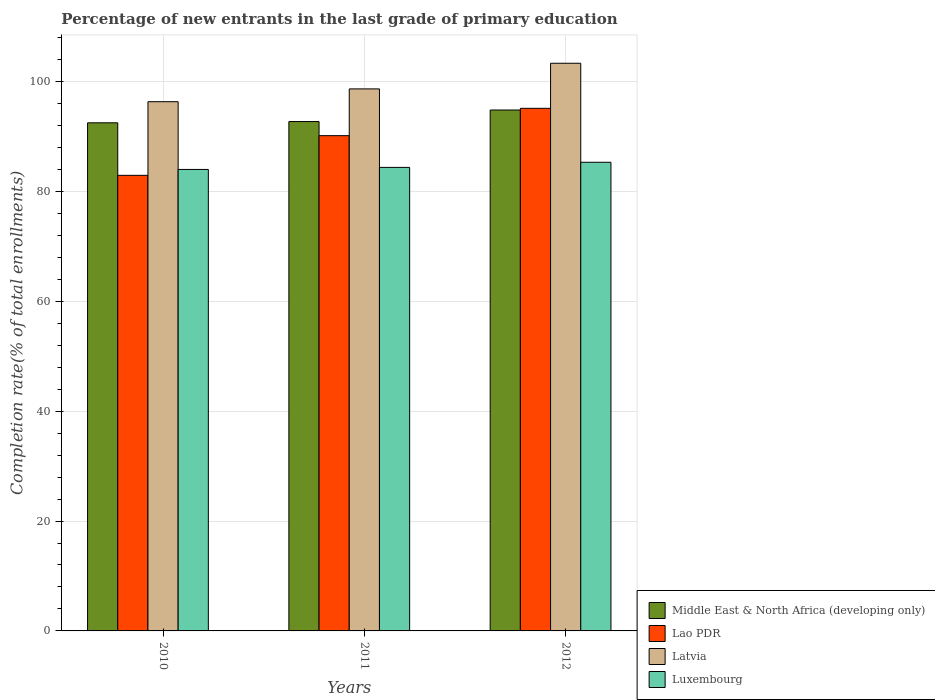How many groups of bars are there?
Provide a short and direct response. 3. Are the number of bars per tick equal to the number of legend labels?
Give a very brief answer. Yes. Are the number of bars on each tick of the X-axis equal?
Give a very brief answer. Yes. How many bars are there on the 3rd tick from the right?
Offer a terse response. 4. What is the label of the 2nd group of bars from the left?
Ensure brevity in your answer.  2011. What is the percentage of new entrants in Lao PDR in 2010?
Offer a very short reply. 82.92. Across all years, what is the maximum percentage of new entrants in Middle East & North Africa (developing only)?
Your answer should be very brief. 94.81. Across all years, what is the minimum percentage of new entrants in Middle East & North Africa (developing only)?
Provide a succinct answer. 92.48. In which year was the percentage of new entrants in Luxembourg minimum?
Ensure brevity in your answer.  2010. What is the total percentage of new entrants in Latvia in the graph?
Make the answer very short. 298.31. What is the difference between the percentage of new entrants in Luxembourg in 2010 and that in 2011?
Your answer should be very brief. -0.37. What is the difference between the percentage of new entrants in Middle East & North Africa (developing only) in 2010 and the percentage of new entrants in Luxembourg in 2012?
Your response must be concise. 7.18. What is the average percentage of new entrants in Latvia per year?
Give a very brief answer. 99.44. In the year 2010, what is the difference between the percentage of new entrants in Middle East & North Africa (developing only) and percentage of new entrants in Lao PDR?
Provide a succinct answer. 9.56. What is the ratio of the percentage of new entrants in Latvia in 2010 to that in 2012?
Offer a very short reply. 0.93. What is the difference between the highest and the second highest percentage of new entrants in Lao PDR?
Keep it short and to the point. 4.98. What is the difference between the highest and the lowest percentage of new entrants in Latvia?
Provide a short and direct response. 7. Is it the case that in every year, the sum of the percentage of new entrants in Lao PDR and percentage of new entrants in Middle East & North Africa (developing only) is greater than the sum of percentage of new entrants in Luxembourg and percentage of new entrants in Latvia?
Ensure brevity in your answer.  No. What does the 4th bar from the left in 2012 represents?
Your response must be concise. Luxembourg. What does the 2nd bar from the right in 2012 represents?
Your response must be concise. Latvia. Is it the case that in every year, the sum of the percentage of new entrants in Luxembourg and percentage of new entrants in Middle East & North Africa (developing only) is greater than the percentage of new entrants in Latvia?
Your answer should be compact. Yes. Does the graph contain grids?
Offer a very short reply. Yes. Where does the legend appear in the graph?
Make the answer very short. Bottom right. How are the legend labels stacked?
Offer a very short reply. Vertical. What is the title of the graph?
Ensure brevity in your answer.  Percentage of new entrants in the last grade of primary education. Does "Belgium" appear as one of the legend labels in the graph?
Offer a very short reply. No. What is the label or title of the Y-axis?
Your response must be concise. Completion rate(% of total enrollments). What is the Completion rate(% of total enrollments) in Middle East & North Africa (developing only) in 2010?
Keep it short and to the point. 92.48. What is the Completion rate(% of total enrollments) of Lao PDR in 2010?
Offer a very short reply. 82.92. What is the Completion rate(% of total enrollments) in Latvia in 2010?
Offer a very short reply. 96.33. What is the Completion rate(% of total enrollments) in Luxembourg in 2010?
Your answer should be compact. 84. What is the Completion rate(% of total enrollments) in Middle East & North Africa (developing only) in 2011?
Offer a terse response. 92.71. What is the Completion rate(% of total enrollments) in Lao PDR in 2011?
Offer a very short reply. 90.14. What is the Completion rate(% of total enrollments) in Latvia in 2011?
Ensure brevity in your answer.  98.66. What is the Completion rate(% of total enrollments) of Luxembourg in 2011?
Offer a terse response. 84.37. What is the Completion rate(% of total enrollments) in Middle East & North Africa (developing only) in 2012?
Keep it short and to the point. 94.81. What is the Completion rate(% of total enrollments) of Lao PDR in 2012?
Provide a short and direct response. 95.12. What is the Completion rate(% of total enrollments) of Latvia in 2012?
Ensure brevity in your answer.  103.32. What is the Completion rate(% of total enrollments) in Luxembourg in 2012?
Your response must be concise. 85.3. Across all years, what is the maximum Completion rate(% of total enrollments) in Middle East & North Africa (developing only)?
Offer a terse response. 94.81. Across all years, what is the maximum Completion rate(% of total enrollments) of Lao PDR?
Offer a very short reply. 95.12. Across all years, what is the maximum Completion rate(% of total enrollments) of Latvia?
Give a very brief answer. 103.32. Across all years, what is the maximum Completion rate(% of total enrollments) in Luxembourg?
Make the answer very short. 85.3. Across all years, what is the minimum Completion rate(% of total enrollments) in Middle East & North Africa (developing only)?
Your answer should be very brief. 92.48. Across all years, what is the minimum Completion rate(% of total enrollments) in Lao PDR?
Keep it short and to the point. 82.92. Across all years, what is the minimum Completion rate(% of total enrollments) of Latvia?
Offer a very short reply. 96.33. Across all years, what is the minimum Completion rate(% of total enrollments) in Luxembourg?
Provide a short and direct response. 84. What is the total Completion rate(% of total enrollments) in Middle East & North Africa (developing only) in the graph?
Offer a terse response. 280.01. What is the total Completion rate(% of total enrollments) in Lao PDR in the graph?
Ensure brevity in your answer.  268.19. What is the total Completion rate(% of total enrollments) in Latvia in the graph?
Offer a very short reply. 298.31. What is the total Completion rate(% of total enrollments) of Luxembourg in the graph?
Offer a terse response. 253.67. What is the difference between the Completion rate(% of total enrollments) of Middle East & North Africa (developing only) in 2010 and that in 2011?
Keep it short and to the point. -0.23. What is the difference between the Completion rate(% of total enrollments) in Lao PDR in 2010 and that in 2011?
Offer a very short reply. -7.22. What is the difference between the Completion rate(% of total enrollments) in Latvia in 2010 and that in 2011?
Your response must be concise. -2.33. What is the difference between the Completion rate(% of total enrollments) of Luxembourg in 2010 and that in 2011?
Your answer should be very brief. -0.37. What is the difference between the Completion rate(% of total enrollments) of Middle East & North Africa (developing only) in 2010 and that in 2012?
Your answer should be compact. -2.33. What is the difference between the Completion rate(% of total enrollments) of Lao PDR in 2010 and that in 2012?
Your answer should be compact. -12.2. What is the difference between the Completion rate(% of total enrollments) of Latvia in 2010 and that in 2012?
Provide a short and direct response. -7. What is the difference between the Completion rate(% of total enrollments) of Luxembourg in 2010 and that in 2012?
Ensure brevity in your answer.  -1.31. What is the difference between the Completion rate(% of total enrollments) of Middle East & North Africa (developing only) in 2011 and that in 2012?
Your answer should be very brief. -2.1. What is the difference between the Completion rate(% of total enrollments) in Lao PDR in 2011 and that in 2012?
Provide a succinct answer. -4.98. What is the difference between the Completion rate(% of total enrollments) of Latvia in 2011 and that in 2012?
Provide a succinct answer. -4.67. What is the difference between the Completion rate(% of total enrollments) in Luxembourg in 2011 and that in 2012?
Keep it short and to the point. -0.93. What is the difference between the Completion rate(% of total enrollments) in Middle East & North Africa (developing only) in 2010 and the Completion rate(% of total enrollments) in Lao PDR in 2011?
Provide a succinct answer. 2.34. What is the difference between the Completion rate(% of total enrollments) of Middle East & North Africa (developing only) in 2010 and the Completion rate(% of total enrollments) of Latvia in 2011?
Provide a short and direct response. -6.17. What is the difference between the Completion rate(% of total enrollments) of Middle East & North Africa (developing only) in 2010 and the Completion rate(% of total enrollments) of Luxembourg in 2011?
Offer a very short reply. 8.12. What is the difference between the Completion rate(% of total enrollments) of Lao PDR in 2010 and the Completion rate(% of total enrollments) of Latvia in 2011?
Provide a succinct answer. -15.73. What is the difference between the Completion rate(% of total enrollments) of Lao PDR in 2010 and the Completion rate(% of total enrollments) of Luxembourg in 2011?
Provide a succinct answer. -1.45. What is the difference between the Completion rate(% of total enrollments) in Latvia in 2010 and the Completion rate(% of total enrollments) in Luxembourg in 2011?
Your answer should be very brief. 11.96. What is the difference between the Completion rate(% of total enrollments) in Middle East & North Africa (developing only) in 2010 and the Completion rate(% of total enrollments) in Lao PDR in 2012?
Offer a terse response. -2.64. What is the difference between the Completion rate(% of total enrollments) of Middle East & North Africa (developing only) in 2010 and the Completion rate(% of total enrollments) of Latvia in 2012?
Provide a short and direct response. -10.84. What is the difference between the Completion rate(% of total enrollments) of Middle East & North Africa (developing only) in 2010 and the Completion rate(% of total enrollments) of Luxembourg in 2012?
Make the answer very short. 7.18. What is the difference between the Completion rate(% of total enrollments) of Lao PDR in 2010 and the Completion rate(% of total enrollments) of Latvia in 2012?
Your answer should be very brief. -20.4. What is the difference between the Completion rate(% of total enrollments) of Lao PDR in 2010 and the Completion rate(% of total enrollments) of Luxembourg in 2012?
Your response must be concise. -2.38. What is the difference between the Completion rate(% of total enrollments) in Latvia in 2010 and the Completion rate(% of total enrollments) in Luxembourg in 2012?
Your answer should be compact. 11.02. What is the difference between the Completion rate(% of total enrollments) of Middle East & North Africa (developing only) in 2011 and the Completion rate(% of total enrollments) of Lao PDR in 2012?
Offer a terse response. -2.41. What is the difference between the Completion rate(% of total enrollments) in Middle East & North Africa (developing only) in 2011 and the Completion rate(% of total enrollments) in Latvia in 2012?
Offer a terse response. -10.61. What is the difference between the Completion rate(% of total enrollments) of Middle East & North Africa (developing only) in 2011 and the Completion rate(% of total enrollments) of Luxembourg in 2012?
Your answer should be compact. 7.41. What is the difference between the Completion rate(% of total enrollments) in Lao PDR in 2011 and the Completion rate(% of total enrollments) in Latvia in 2012?
Offer a very short reply. -13.18. What is the difference between the Completion rate(% of total enrollments) of Lao PDR in 2011 and the Completion rate(% of total enrollments) of Luxembourg in 2012?
Provide a short and direct response. 4.84. What is the difference between the Completion rate(% of total enrollments) in Latvia in 2011 and the Completion rate(% of total enrollments) in Luxembourg in 2012?
Offer a very short reply. 13.36. What is the average Completion rate(% of total enrollments) in Middle East & North Africa (developing only) per year?
Your response must be concise. 93.34. What is the average Completion rate(% of total enrollments) of Lao PDR per year?
Keep it short and to the point. 89.4. What is the average Completion rate(% of total enrollments) in Latvia per year?
Keep it short and to the point. 99.44. What is the average Completion rate(% of total enrollments) of Luxembourg per year?
Your answer should be compact. 84.56. In the year 2010, what is the difference between the Completion rate(% of total enrollments) in Middle East & North Africa (developing only) and Completion rate(% of total enrollments) in Lao PDR?
Your answer should be compact. 9.56. In the year 2010, what is the difference between the Completion rate(% of total enrollments) of Middle East & North Africa (developing only) and Completion rate(% of total enrollments) of Latvia?
Your answer should be very brief. -3.84. In the year 2010, what is the difference between the Completion rate(% of total enrollments) in Middle East & North Africa (developing only) and Completion rate(% of total enrollments) in Luxembourg?
Offer a very short reply. 8.49. In the year 2010, what is the difference between the Completion rate(% of total enrollments) in Lao PDR and Completion rate(% of total enrollments) in Latvia?
Provide a succinct answer. -13.4. In the year 2010, what is the difference between the Completion rate(% of total enrollments) in Lao PDR and Completion rate(% of total enrollments) in Luxembourg?
Offer a terse response. -1.07. In the year 2010, what is the difference between the Completion rate(% of total enrollments) of Latvia and Completion rate(% of total enrollments) of Luxembourg?
Keep it short and to the point. 12.33. In the year 2011, what is the difference between the Completion rate(% of total enrollments) of Middle East & North Africa (developing only) and Completion rate(% of total enrollments) of Lao PDR?
Keep it short and to the point. 2.57. In the year 2011, what is the difference between the Completion rate(% of total enrollments) of Middle East & North Africa (developing only) and Completion rate(% of total enrollments) of Latvia?
Give a very brief answer. -5.94. In the year 2011, what is the difference between the Completion rate(% of total enrollments) of Middle East & North Africa (developing only) and Completion rate(% of total enrollments) of Luxembourg?
Your response must be concise. 8.34. In the year 2011, what is the difference between the Completion rate(% of total enrollments) in Lao PDR and Completion rate(% of total enrollments) in Latvia?
Keep it short and to the point. -8.51. In the year 2011, what is the difference between the Completion rate(% of total enrollments) of Lao PDR and Completion rate(% of total enrollments) of Luxembourg?
Make the answer very short. 5.78. In the year 2011, what is the difference between the Completion rate(% of total enrollments) of Latvia and Completion rate(% of total enrollments) of Luxembourg?
Ensure brevity in your answer.  14.29. In the year 2012, what is the difference between the Completion rate(% of total enrollments) of Middle East & North Africa (developing only) and Completion rate(% of total enrollments) of Lao PDR?
Your response must be concise. -0.31. In the year 2012, what is the difference between the Completion rate(% of total enrollments) in Middle East & North Africa (developing only) and Completion rate(% of total enrollments) in Latvia?
Provide a succinct answer. -8.51. In the year 2012, what is the difference between the Completion rate(% of total enrollments) of Middle East & North Africa (developing only) and Completion rate(% of total enrollments) of Luxembourg?
Give a very brief answer. 9.51. In the year 2012, what is the difference between the Completion rate(% of total enrollments) of Lao PDR and Completion rate(% of total enrollments) of Latvia?
Provide a short and direct response. -8.2. In the year 2012, what is the difference between the Completion rate(% of total enrollments) in Lao PDR and Completion rate(% of total enrollments) in Luxembourg?
Ensure brevity in your answer.  9.82. In the year 2012, what is the difference between the Completion rate(% of total enrollments) of Latvia and Completion rate(% of total enrollments) of Luxembourg?
Provide a short and direct response. 18.02. What is the ratio of the Completion rate(% of total enrollments) of Middle East & North Africa (developing only) in 2010 to that in 2011?
Offer a terse response. 1. What is the ratio of the Completion rate(% of total enrollments) in Lao PDR in 2010 to that in 2011?
Your response must be concise. 0.92. What is the ratio of the Completion rate(% of total enrollments) in Latvia in 2010 to that in 2011?
Ensure brevity in your answer.  0.98. What is the ratio of the Completion rate(% of total enrollments) in Luxembourg in 2010 to that in 2011?
Keep it short and to the point. 1. What is the ratio of the Completion rate(% of total enrollments) of Middle East & North Africa (developing only) in 2010 to that in 2012?
Your answer should be compact. 0.98. What is the ratio of the Completion rate(% of total enrollments) of Lao PDR in 2010 to that in 2012?
Provide a short and direct response. 0.87. What is the ratio of the Completion rate(% of total enrollments) in Latvia in 2010 to that in 2012?
Your response must be concise. 0.93. What is the ratio of the Completion rate(% of total enrollments) in Luxembourg in 2010 to that in 2012?
Make the answer very short. 0.98. What is the ratio of the Completion rate(% of total enrollments) of Middle East & North Africa (developing only) in 2011 to that in 2012?
Keep it short and to the point. 0.98. What is the ratio of the Completion rate(% of total enrollments) in Lao PDR in 2011 to that in 2012?
Your answer should be compact. 0.95. What is the ratio of the Completion rate(% of total enrollments) of Latvia in 2011 to that in 2012?
Your answer should be compact. 0.95. What is the ratio of the Completion rate(% of total enrollments) of Luxembourg in 2011 to that in 2012?
Offer a very short reply. 0.99. What is the difference between the highest and the second highest Completion rate(% of total enrollments) of Middle East & North Africa (developing only)?
Provide a short and direct response. 2.1. What is the difference between the highest and the second highest Completion rate(% of total enrollments) of Lao PDR?
Provide a succinct answer. 4.98. What is the difference between the highest and the second highest Completion rate(% of total enrollments) of Latvia?
Make the answer very short. 4.67. What is the difference between the highest and the second highest Completion rate(% of total enrollments) of Luxembourg?
Provide a short and direct response. 0.93. What is the difference between the highest and the lowest Completion rate(% of total enrollments) in Middle East & North Africa (developing only)?
Make the answer very short. 2.33. What is the difference between the highest and the lowest Completion rate(% of total enrollments) of Lao PDR?
Offer a terse response. 12.2. What is the difference between the highest and the lowest Completion rate(% of total enrollments) of Latvia?
Give a very brief answer. 7. What is the difference between the highest and the lowest Completion rate(% of total enrollments) in Luxembourg?
Offer a very short reply. 1.31. 